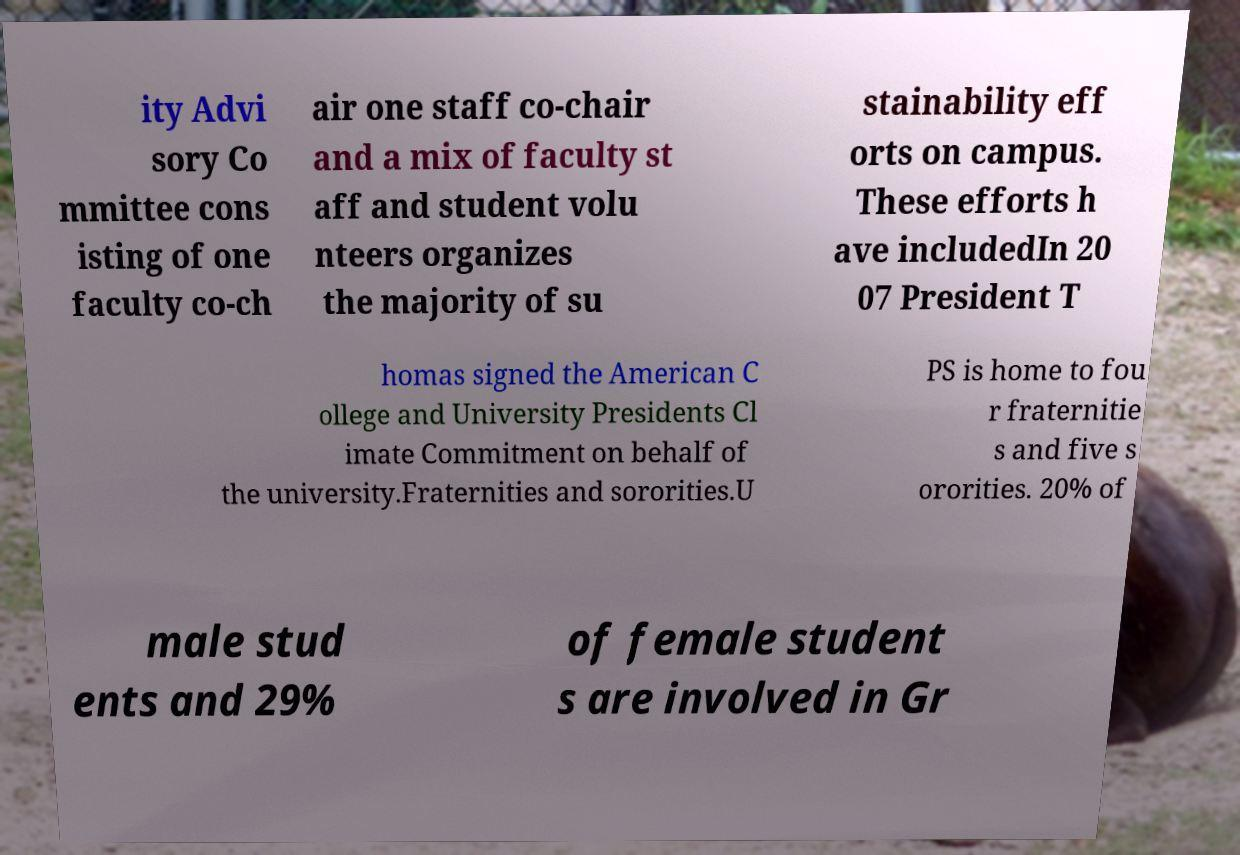Please read and relay the text visible in this image. What does it say? ity Advi sory Co mmittee cons isting of one faculty co-ch air one staff co-chair and a mix of faculty st aff and student volu nteers organizes the majority of su stainability eff orts on campus. These efforts h ave includedIn 20 07 President T homas signed the American C ollege and University Presidents Cl imate Commitment on behalf of the university.Fraternities and sororities.U PS is home to fou r fraternitie s and five s ororities. 20% of male stud ents and 29% of female student s are involved in Gr 